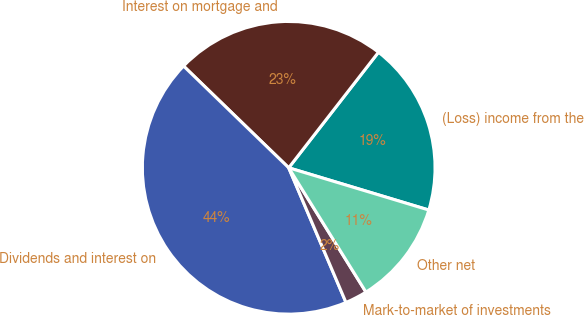Convert chart. <chart><loc_0><loc_0><loc_500><loc_500><pie_chart><fcel>(Loss) income from the<fcel>Interest on mortgage and<fcel>Dividends and interest on<fcel>Mark-to-market of investments<fcel>Other net<nl><fcel>19.15%<fcel>23.27%<fcel>43.64%<fcel>2.45%<fcel>11.49%<nl></chart> 